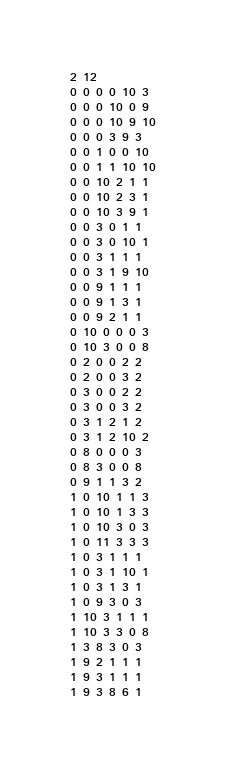Convert code to text. <code><loc_0><loc_0><loc_500><loc_500><_SQL_>2 12
0 0 0 0 10 3
0 0 0 10 0 9
0 0 0 10 9 10
0 0 0 3 9 3
0 0 1 0 0 10
0 0 1 1 10 10
0 0 10 2 1 1
0 0 10 2 3 1
0 0 10 3 9 1
0 0 3 0 1 1
0 0 3 0 10 1
0 0 3 1 1 1
0 0 3 1 9 10
0 0 9 1 1 1
0 0 9 1 3 1
0 0 9 2 1 1
0 10 0 0 0 3
0 10 3 0 0 8
0 2 0 0 2 2
0 2 0 0 3 2
0 3 0 0 2 2
0 3 0 0 3 2
0 3 1 2 1 2
0 3 1 2 10 2
0 8 0 0 0 3
0 8 3 0 0 8
0 9 1 1 3 2
1 0 10 1 1 3
1 0 10 1 3 3
1 0 10 3 0 3
1 0 11 3 3 3
1 0 3 1 1 1
1 0 3 1 10 1
1 0 3 1 3 1
1 0 9 3 0 3
1 10 3 1 1 1
1 10 3 3 0 8
1 3 8 3 0 3
1 9 2 1 1 1
1 9 3 1 1 1
1 9 3 8 6 1</code> 